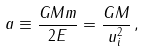Convert formula to latex. <formula><loc_0><loc_0><loc_500><loc_500>a \equiv \frac { G M m } { 2 E } = \frac { G M } { u _ { i } ^ { 2 } } \, ,</formula> 